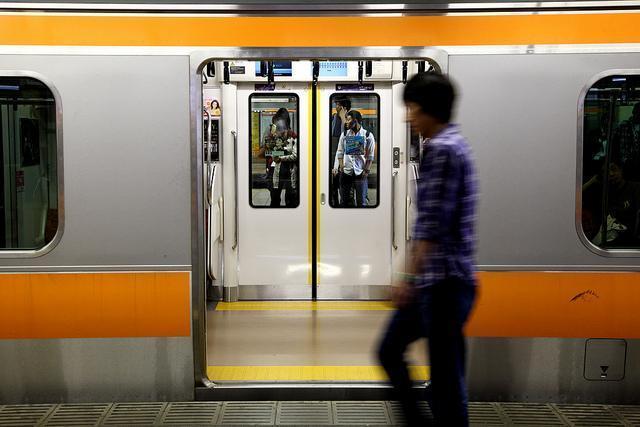How many people are there?
Give a very brief answer. 4. How many donuts have chocolate frosting?
Give a very brief answer. 0. 